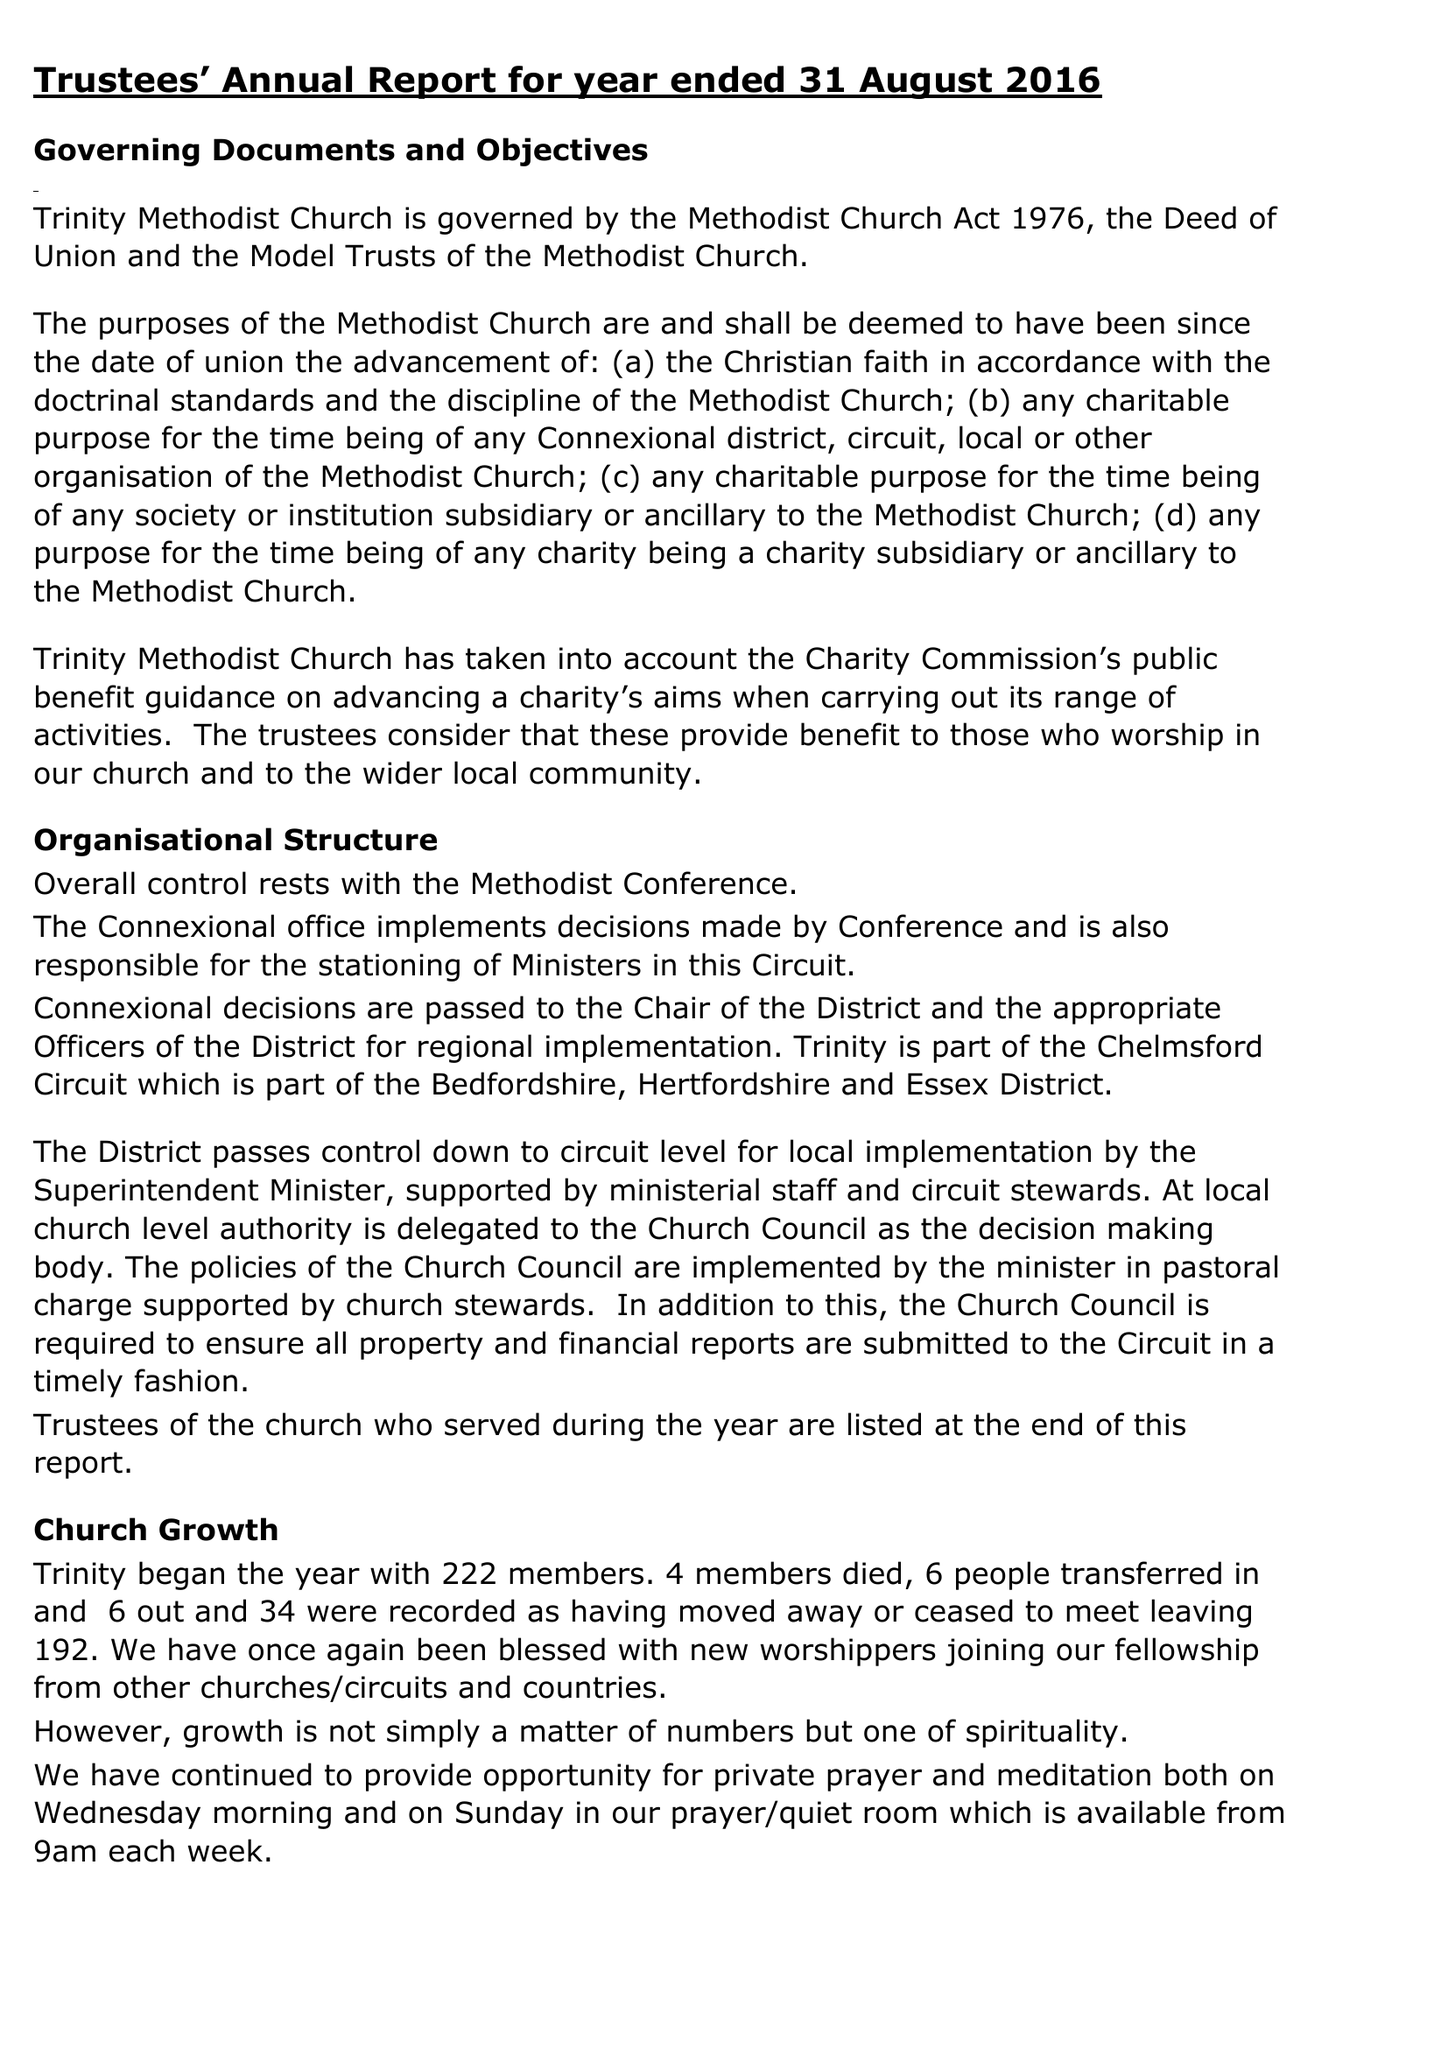What is the value for the charity_number?
Answer the question using a single word or phrase. 1144617 